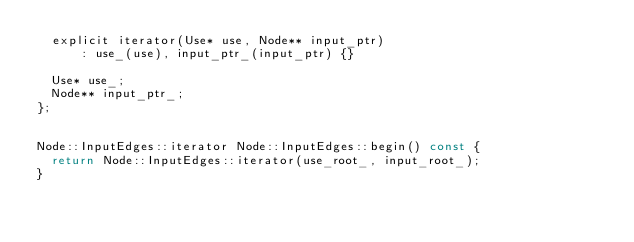Convert code to text. <code><loc_0><loc_0><loc_500><loc_500><_C_>  explicit iterator(Use* use, Node** input_ptr)
      : use_(use), input_ptr_(input_ptr) {}

  Use* use_;
  Node** input_ptr_;
};


Node::InputEdges::iterator Node::InputEdges::begin() const {
  return Node::InputEdges::iterator(use_root_, input_root_);
}

</code> 